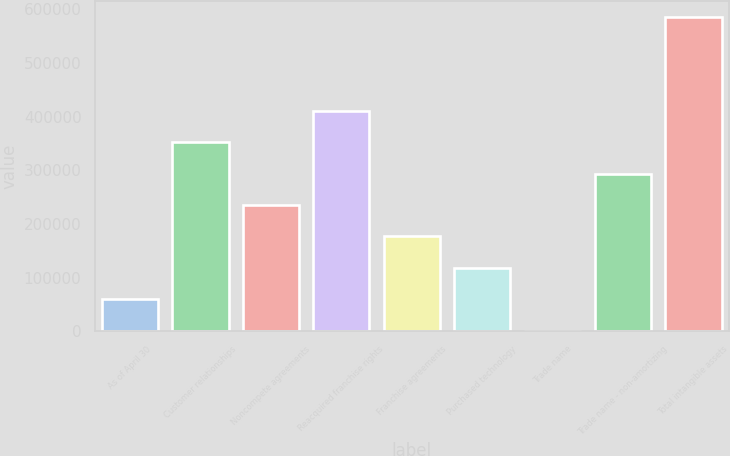Convert chart to OTSL. <chart><loc_0><loc_0><loc_500><loc_500><bar_chart><fcel>As of April 30<fcel>Customer relationships<fcel>Noncompete agreements<fcel>Reacquired franchise rights<fcel>Franchise agreements<fcel>Purchased technology<fcel>Trade name<fcel>Trade name - non-amortizing<fcel>Total intangible assets<nl><fcel>59792.9<fcel>352132<fcel>235197<fcel>410600<fcel>176729<fcel>118261<fcel>1325<fcel>293664<fcel>586004<nl></chart> 